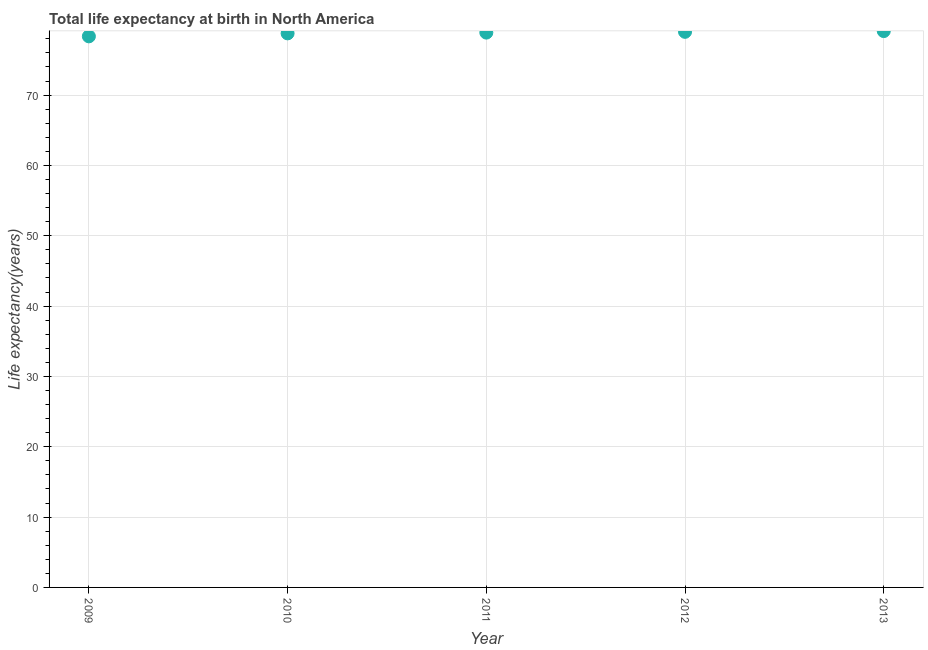What is the life expectancy at birth in 2013?
Ensure brevity in your answer.  79.1. Across all years, what is the maximum life expectancy at birth?
Keep it short and to the point. 79.1. Across all years, what is the minimum life expectancy at birth?
Make the answer very short. 78.35. In which year was the life expectancy at birth minimum?
Your answer should be compact. 2009. What is the sum of the life expectancy at birth?
Provide a succinct answer. 394.1. What is the difference between the life expectancy at birth in 2009 and 2011?
Ensure brevity in your answer.  -0.53. What is the average life expectancy at birth per year?
Your answer should be compact. 78.82. What is the median life expectancy at birth?
Provide a succinct answer. 78.88. In how many years, is the life expectancy at birth greater than 34 years?
Keep it short and to the point. 5. Do a majority of the years between 2012 and 2009 (inclusive) have life expectancy at birth greater than 24 years?
Your answer should be compact. Yes. What is the ratio of the life expectancy at birth in 2009 to that in 2013?
Make the answer very short. 0.99. What is the difference between the highest and the second highest life expectancy at birth?
Make the answer very short. 0.11. What is the difference between the highest and the lowest life expectancy at birth?
Provide a short and direct response. 0.75. How many dotlines are there?
Offer a very short reply. 1. Are the values on the major ticks of Y-axis written in scientific E-notation?
Provide a succinct answer. No. Does the graph contain grids?
Provide a succinct answer. Yes. What is the title of the graph?
Make the answer very short. Total life expectancy at birth in North America. What is the label or title of the X-axis?
Keep it short and to the point. Year. What is the label or title of the Y-axis?
Your response must be concise. Life expectancy(years). What is the Life expectancy(years) in 2009?
Ensure brevity in your answer.  78.35. What is the Life expectancy(years) in 2010?
Your response must be concise. 78.77. What is the Life expectancy(years) in 2011?
Ensure brevity in your answer.  78.88. What is the Life expectancy(years) in 2012?
Make the answer very short. 78.99. What is the Life expectancy(years) in 2013?
Give a very brief answer. 79.1. What is the difference between the Life expectancy(years) in 2009 and 2010?
Your answer should be compact. -0.42. What is the difference between the Life expectancy(years) in 2009 and 2011?
Offer a very short reply. -0.53. What is the difference between the Life expectancy(years) in 2009 and 2012?
Your answer should be very brief. -0.64. What is the difference between the Life expectancy(years) in 2009 and 2013?
Your answer should be very brief. -0.75. What is the difference between the Life expectancy(years) in 2010 and 2011?
Provide a short and direct response. -0.11. What is the difference between the Life expectancy(years) in 2010 and 2012?
Your response must be concise. -0.22. What is the difference between the Life expectancy(years) in 2010 and 2013?
Your response must be concise. -0.32. What is the difference between the Life expectancy(years) in 2011 and 2012?
Provide a succinct answer. -0.11. What is the difference between the Life expectancy(years) in 2011 and 2013?
Offer a very short reply. -0.21. What is the difference between the Life expectancy(years) in 2012 and 2013?
Your response must be concise. -0.11. What is the ratio of the Life expectancy(years) in 2009 to that in 2010?
Provide a short and direct response. 0.99. What is the ratio of the Life expectancy(years) in 2009 to that in 2011?
Your answer should be very brief. 0.99. What is the ratio of the Life expectancy(years) in 2010 to that in 2011?
Your response must be concise. 1. What is the ratio of the Life expectancy(years) in 2011 to that in 2012?
Ensure brevity in your answer.  1. 